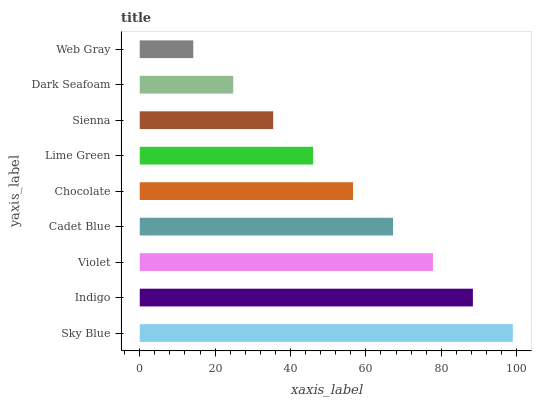Is Web Gray the minimum?
Answer yes or no. Yes. Is Sky Blue the maximum?
Answer yes or no. Yes. Is Indigo the minimum?
Answer yes or no. No. Is Indigo the maximum?
Answer yes or no. No. Is Sky Blue greater than Indigo?
Answer yes or no. Yes. Is Indigo less than Sky Blue?
Answer yes or no. Yes. Is Indigo greater than Sky Blue?
Answer yes or no. No. Is Sky Blue less than Indigo?
Answer yes or no. No. Is Chocolate the high median?
Answer yes or no. Yes. Is Chocolate the low median?
Answer yes or no. Yes. Is Indigo the high median?
Answer yes or no. No. Is Lime Green the low median?
Answer yes or no. No. 